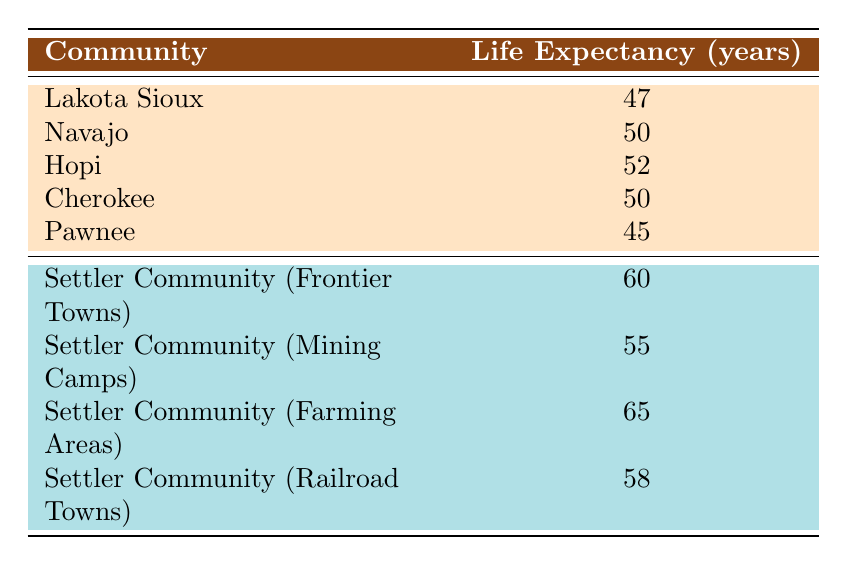What is the life expectancy of the Navajo tribe? The Navajo tribe's life expectancy is directly listed in the table under the "life expectancy" column next to the "Navajo" row. The value is 50 years.
Answer: 50 Which settler community has the highest life expectancy? By looking at the "Settler Community" rows in the table, we can see that "Settler Community (Farming Areas)" has the highest life expectancy of 65 years compared to all other settler communities listed.
Answer: Settler Community (Farming Areas) What is the difference in life expectancy between the Pawnee and the Hopi? The life expectancy of the Pawnee is 45 years, while the Hopi's life expectancy is 52 years. To find the difference, we subtract 45 from 52, which gives us 7 years.
Answer: 7 Is the life expectancy of the Cherokee tribe higher than that of the Lakota Sioux? The life expectancy of the Cherokee is 50 years, and for the Lakota Sioux, it is 47 years. 50 is greater than 47, so the statement is true.
Answer: Yes What is the average life expectancy of all Native American tribes listed in the table? The Native American tribes and their life expectancies are: Lakota Sioux (47), Navajo (50), Hopi (52), Cherokee (50), and Pawnee (45). To calculate the average: (47 + 50 + 52 + 50 + 45) = 244 and divide by 5, which gives an average of 48.8.
Answer: 48.8 What is the combined life expectancy of all settler communities listed in the table? We add up the life expectancies of the settler communities: 60 (Frontier Towns) + 55 (Mining Camps) + 65 (Farming Areas) + 58 (Railroad Towns) = 238.
Answer: 238 Which Native American tribe has life expectancy closest to the settler community life expectancy of 60 years? The life expectancy of the settler community (Frontier Towns) is 60 years. The life expectancies for Native American tribes are 47 (Lakota Sioux), 50 (Navajo), 52 (Hopi), 50 (Cherokee), and 45 (Pawnee). The closest to 60 is 52 from the Hopi tribe, making it the most similar.
Answer: Hopi Which group overall has a higher life expectancy: Native American tribes or settler communities? The average life expectancy of Native American tribes is (47 + 50 + 52 + 50 + 45) / 5 = 48.8, while for settler communities: (60 + 55 + 65 + 58) / 4 = 59.5. Since 59.5 is greater than 48.8, settler communities overall have a higher life expectancy.
Answer: Settler communities 